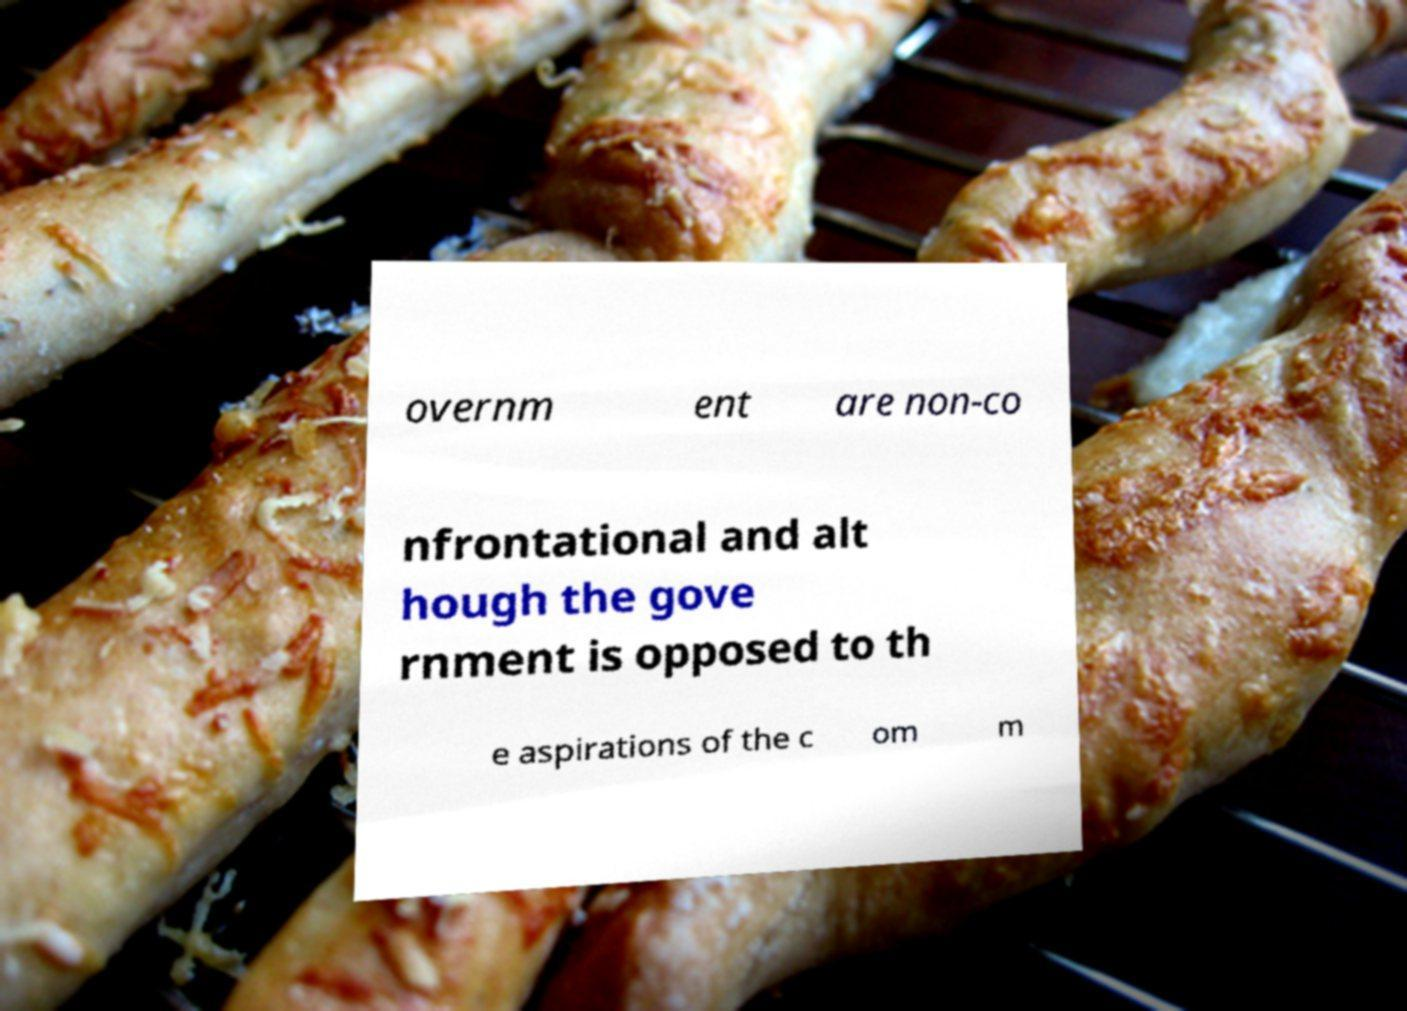For documentation purposes, I need the text within this image transcribed. Could you provide that? overnm ent are non-co nfrontational and alt hough the gove rnment is opposed to th e aspirations of the c om m 